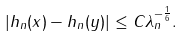Convert formula to latex. <formula><loc_0><loc_0><loc_500><loc_500>| h _ { n } ( x ) - h _ { n } ( y ) | \leq C \lambda _ { n } ^ { - \frac { 1 } { 6 } } .</formula> 